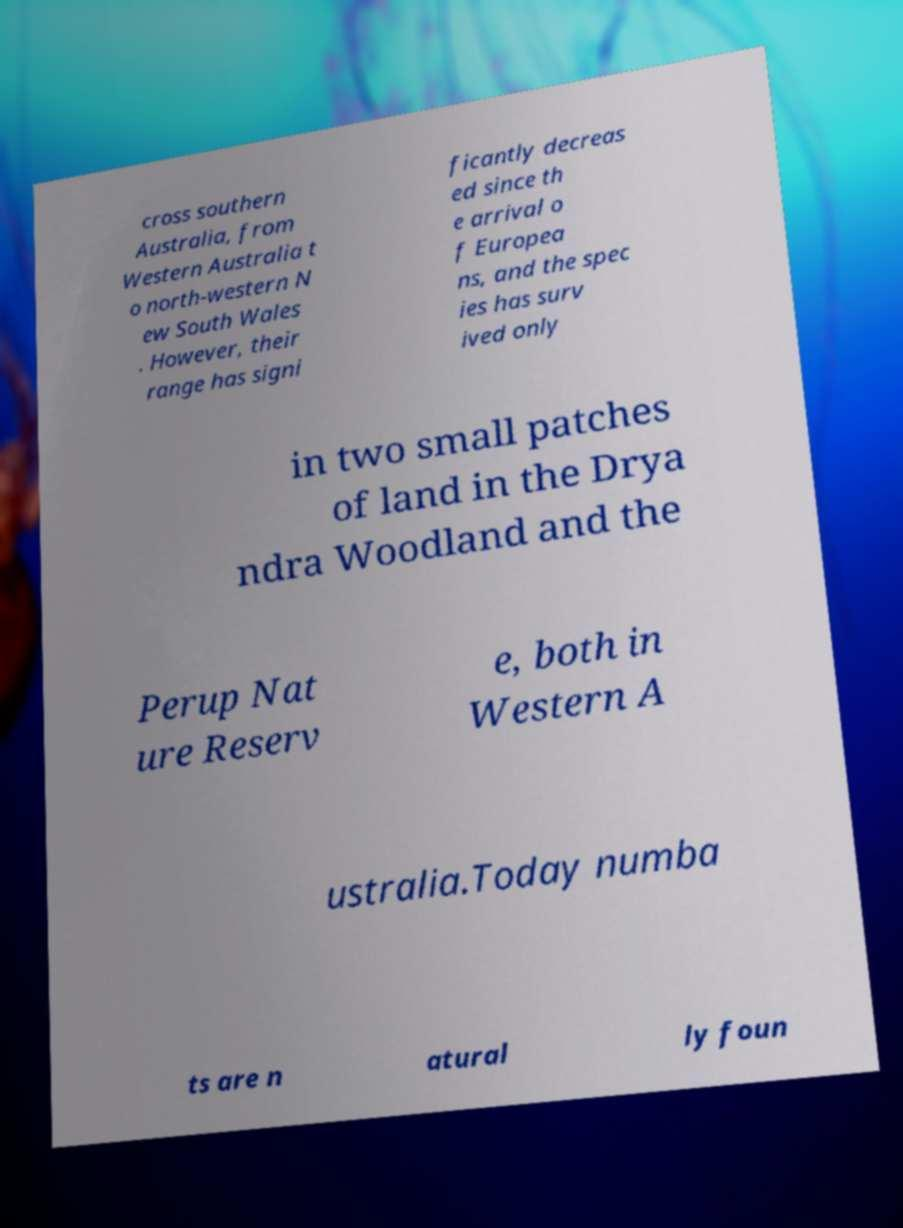What messages or text are displayed in this image? I need them in a readable, typed format. cross southern Australia, from Western Australia t o north-western N ew South Wales . However, their range has signi ficantly decreas ed since th e arrival o f Europea ns, and the spec ies has surv ived only in two small patches of land in the Drya ndra Woodland and the Perup Nat ure Reserv e, both in Western A ustralia.Today numba ts are n atural ly foun 